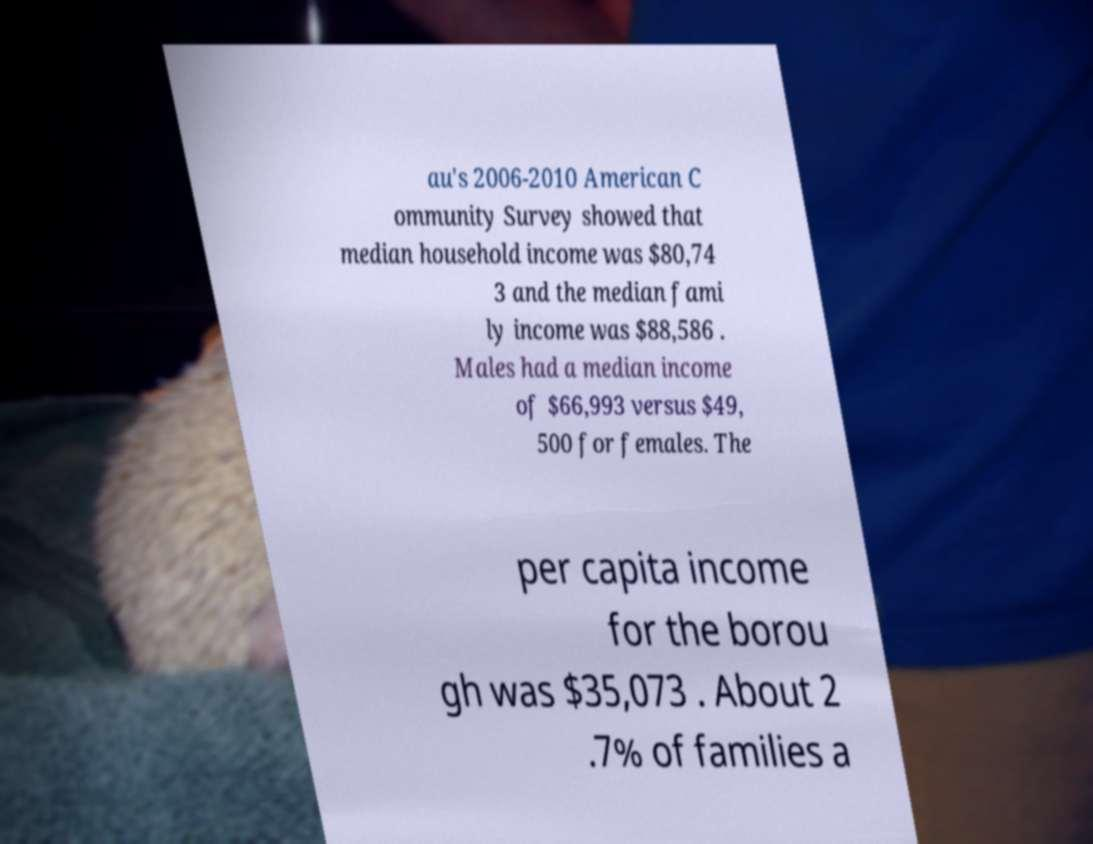There's text embedded in this image that I need extracted. Can you transcribe it verbatim? au's 2006-2010 American C ommunity Survey showed that median household income was $80,74 3 and the median fami ly income was $88,586 . Males had a median income of $66,993 versus $49, 500 for females. The per capita income for the borou gh was $35,073 . About 2 .7% of families a 